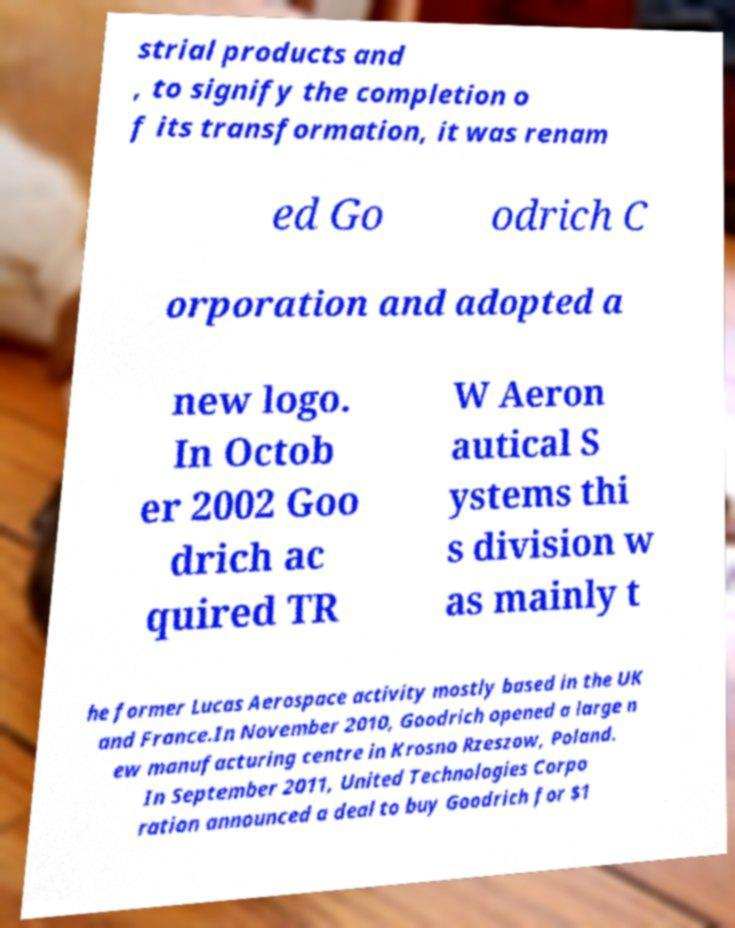For documentation purposes, I need the text within this image transcribed. Could you provide that? strial products and , to signify the completion o f its transformation, it was renam ed Go odrich C orporation and adopted a new logo. In Octob er 2002 Goo drich ac quired TR W Aeron autical S ystems thi s division w as mainly t he former Lucas Aerospace activity mostly based in the UK and France.In November 2010, Goodrich opened a large n ew manufacturing centre in Krosno Rzeszow, Poland. In September 2011, United Technologies Corpo ration announced a deal to buy Goodrich for $1 